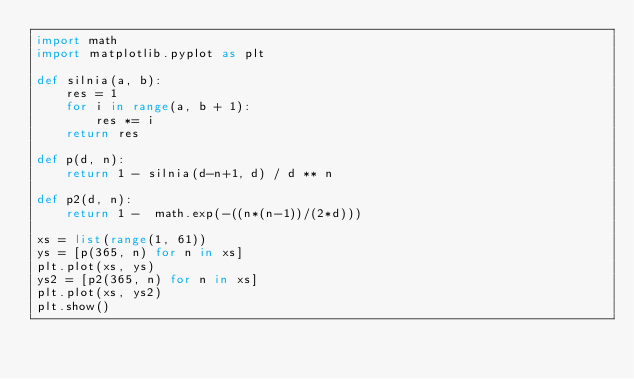<code> <loc_0><loc_0><loc_500><loc_500><_Python_>import math
import matplotlib.pyplot as plt

def silnia(a, b):
    res = 1
    for i in range(a, b + 1):
        res *= i
    return res
    
def p(d, n):
    return 1 - silnia(d-n+1, d) / d ** n

def p2(d, n):
    return 1 -  math.exp(-((n*(n-1))/(2*d)))
    
xs = list(range(1, 61))
ys = [p(365, n) for n in xs]
plt.plot(xs, ys)
ys2 = [p2(365, n) for n in xs]
plt.plot(xs, ys2)
plt.show()</code> 